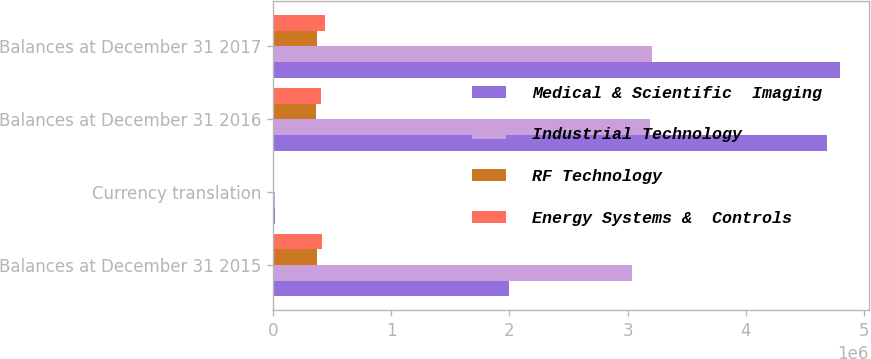<chart> <loc_0><loc_0><loc_500><loc_500><stacked_bar_chart><ecel><fcel>Balances at December 31 2015<fcel>Currency translation<fcel>Balances at December 31 2016<fcel>Balances at December 31 2017<nl><fcel>Medical & Scientific  Imaging<fcel>1.9933e+06<fcel>15118<fcel>4.68767e+06<fcel>4.79889e+06<nl><fcel>Industrial Technology<fcel>3.0392e+06<fcel>19100<fcel>3.18507e+06<fcel>3.20592e+06<nl><fcel>RF Technology<fcel>374033<fcel>10055<fcel>363978<fcel>377518<nl><fcel>Energy Systems &  Controls<fcel>418197<fcel>7774<fcel>410423<fcel>437987<nl></chart> 